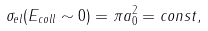<formula> <loc_0><loc_0><loc_500><loc_500>\sigma _ { e l } ( E _ { c o l l } \sim 0 ) = \pi a _ { 0 } ^ { 2 } = c o n s t ,</formula> 